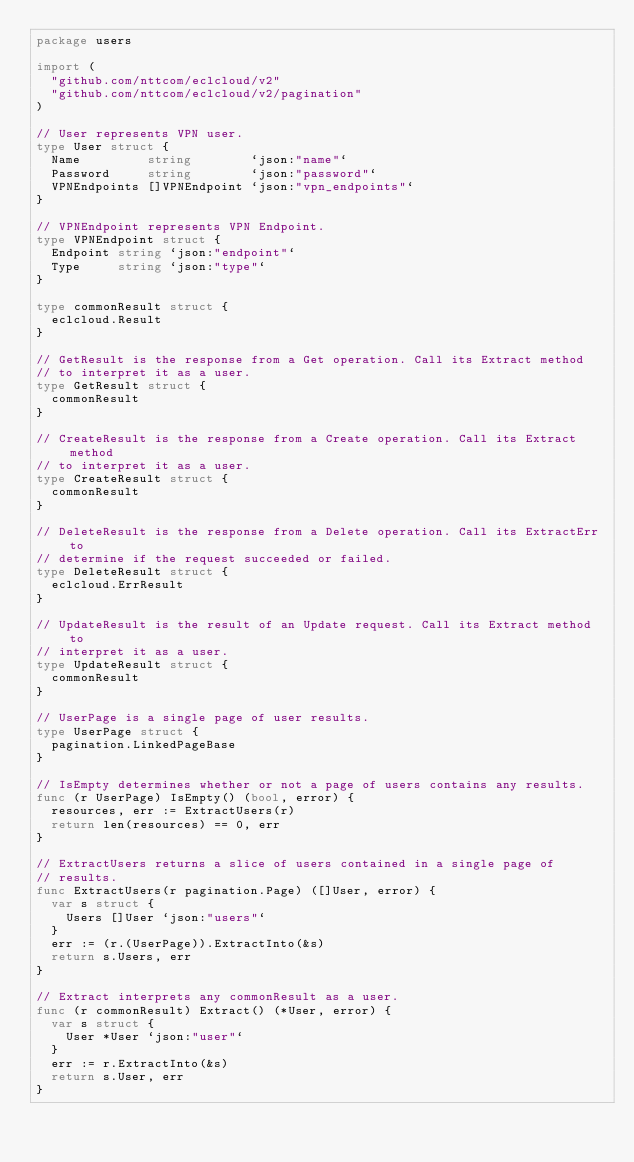Convert code to text. <code><loc_0><loc_0><loc_500><loc_500><_Go_>package users

import (
	"github.com/nttcom/eclcloud/v2"
	"github.com/nttcom/eclcloud/v2/pagination"
)

// User represents VPN user.
type User struct {
	Name         string        `json:"name"`
	Password     string        `json:"password"`
	VPNEndpoints []VPNEndpoint `json:"vpn_endpoints"`
}

// VPNEndpoint represents VPN Endpoint.
type VPNEndpoint struct {
	Endpoint string `json:"endpoint"`
	Type     string `json:"type"`
}

type commonResult struct {
	eclcloud.Result
}

// GetResult is the response from a Get operation. Call its Extract method
// to interpret it as a user.
type GetResult struct {
	commonResult
}

// CreateResult is the response from a Create operation. Call its Extract method
// to interpret it as a user.
type CreateResult struct {
	commonResult
}

// DeleteResult is the response from a Delete operation. Call its ExtractErr to
// determine if the request succeeded or failed.
type DeleteResult struct {
	eclcloud.ErrResult
}

// UpdateResult is the result of an Update request. Call its Extract method to
// interpret it as a user.
type UpdateResult struct {
	commonResult
}

// UserPage is a single page of user results.
type UserPage struct {
	pagination.LinkedPageBase
}

// IsEmpty determines whether or not a page of users contains any results.
func (r UserPage) IsEmpty() (bool, error) {
	resources, err := ExtractUsers(r)
	return len(resources) == 0, err
}

// ExtractUsers returns a slice of users contained in a single page of
// results.
func ExtractUsers(r pagination.Page) ([]User, error) {
	var s struct {
		Users []User `json:"users"`
	}
	err := (r.(UserPage)).ExtractInto(&s)
	return s.Users, err
}

// Extract interprets any commonResult as a user.
func (r commonResult) Extract() (*User, error) {
	var s struct {
		User *User `json:"user"`
	}
	err := r.ExtractInto(&s)
	return s.User, err
}
</code> 